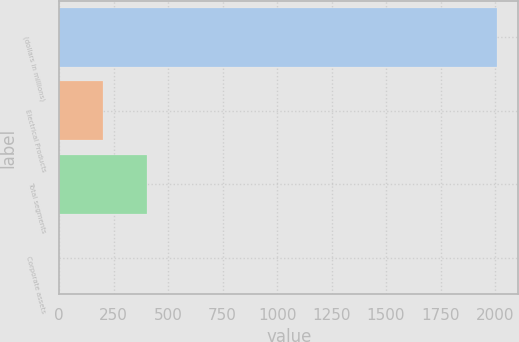Convert chart. <chart><loc_0><loc_0><loc_500><loc_500><bar_chart><fcel>(dollars in millions)<fcel>Electrical Products<fcel>Total segments<fcel>Corporate assets<nl><fcel>2007<fcel>201.15<fcel>401.8<fcel>0.5<nl></chart> 